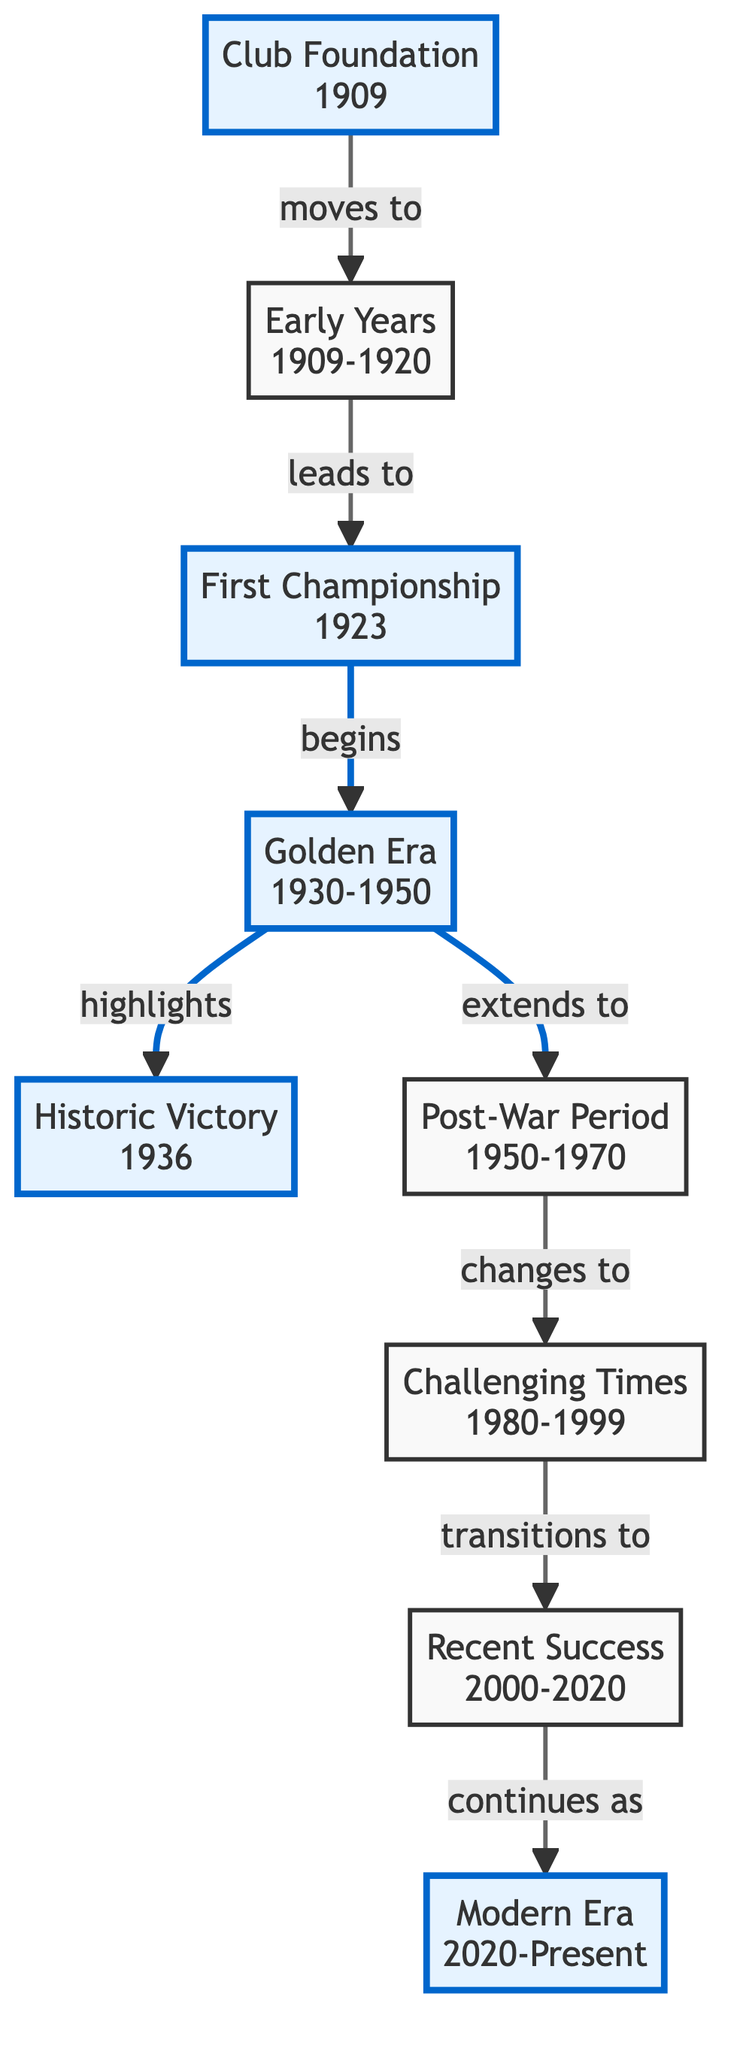What year was Sliema Wanderers FC established? The node "Club Foundation" clearly states the year 1909, indicating when Sliema Wanderers FC was founded.
Answer: 1909 What does the "Early Years" section refer to? The node labeled "Early Years" (1909-1920) indicates that the club participated in regional competitions during this time period.
Answer: Regional competitions Which event marks the beginning of the Golden Era? The diagram shows that the "First Championship" in 1923 leads to the "Golden Era," indicating that this championship marks the beginning of that period.
Answer: First Championship How many years did the Golden Era last? The "Golden Era" node covers the years from 1930 to 1950, which is a span of 20 years.
Answer: 20 years What significant victory is highlighted in the Golden Era? The "Historic Victory" node under the "Golden Era" specifically mentions a memorable win against Valletta F.C. in 1936, highlighting this victory within that era.
Answer: Memorable win against Valletta F.C What period followed the Post-War Period in the club's history? The "Challenging Times" section follows the "Post-War Period" according to the linked relationships in the diagram, indicating the transition in the club’s performance during that time.
Answer: Challenging Times During which years did Sliema Wanderers experience Recent Success? The node labeled "Recent Success" indicates a period from 2000 to 2020, showing the years during which the club revived its performances.
Answer: 2000-2020 What led to the club's Modern Era? The transition from "Recent Success" to "Modern Era" shows that Sliema Wanderers’ revival in the earlier years continues into the current period, marking the progression of the club.
Answer: Recent Success What strategic actions are noted in the Modern Era? The "Modern Era" node mentions "Strategic investments and youth development programs" as the actions being focused upon during the current period.
Answer: Strategic investments and youth development programs 